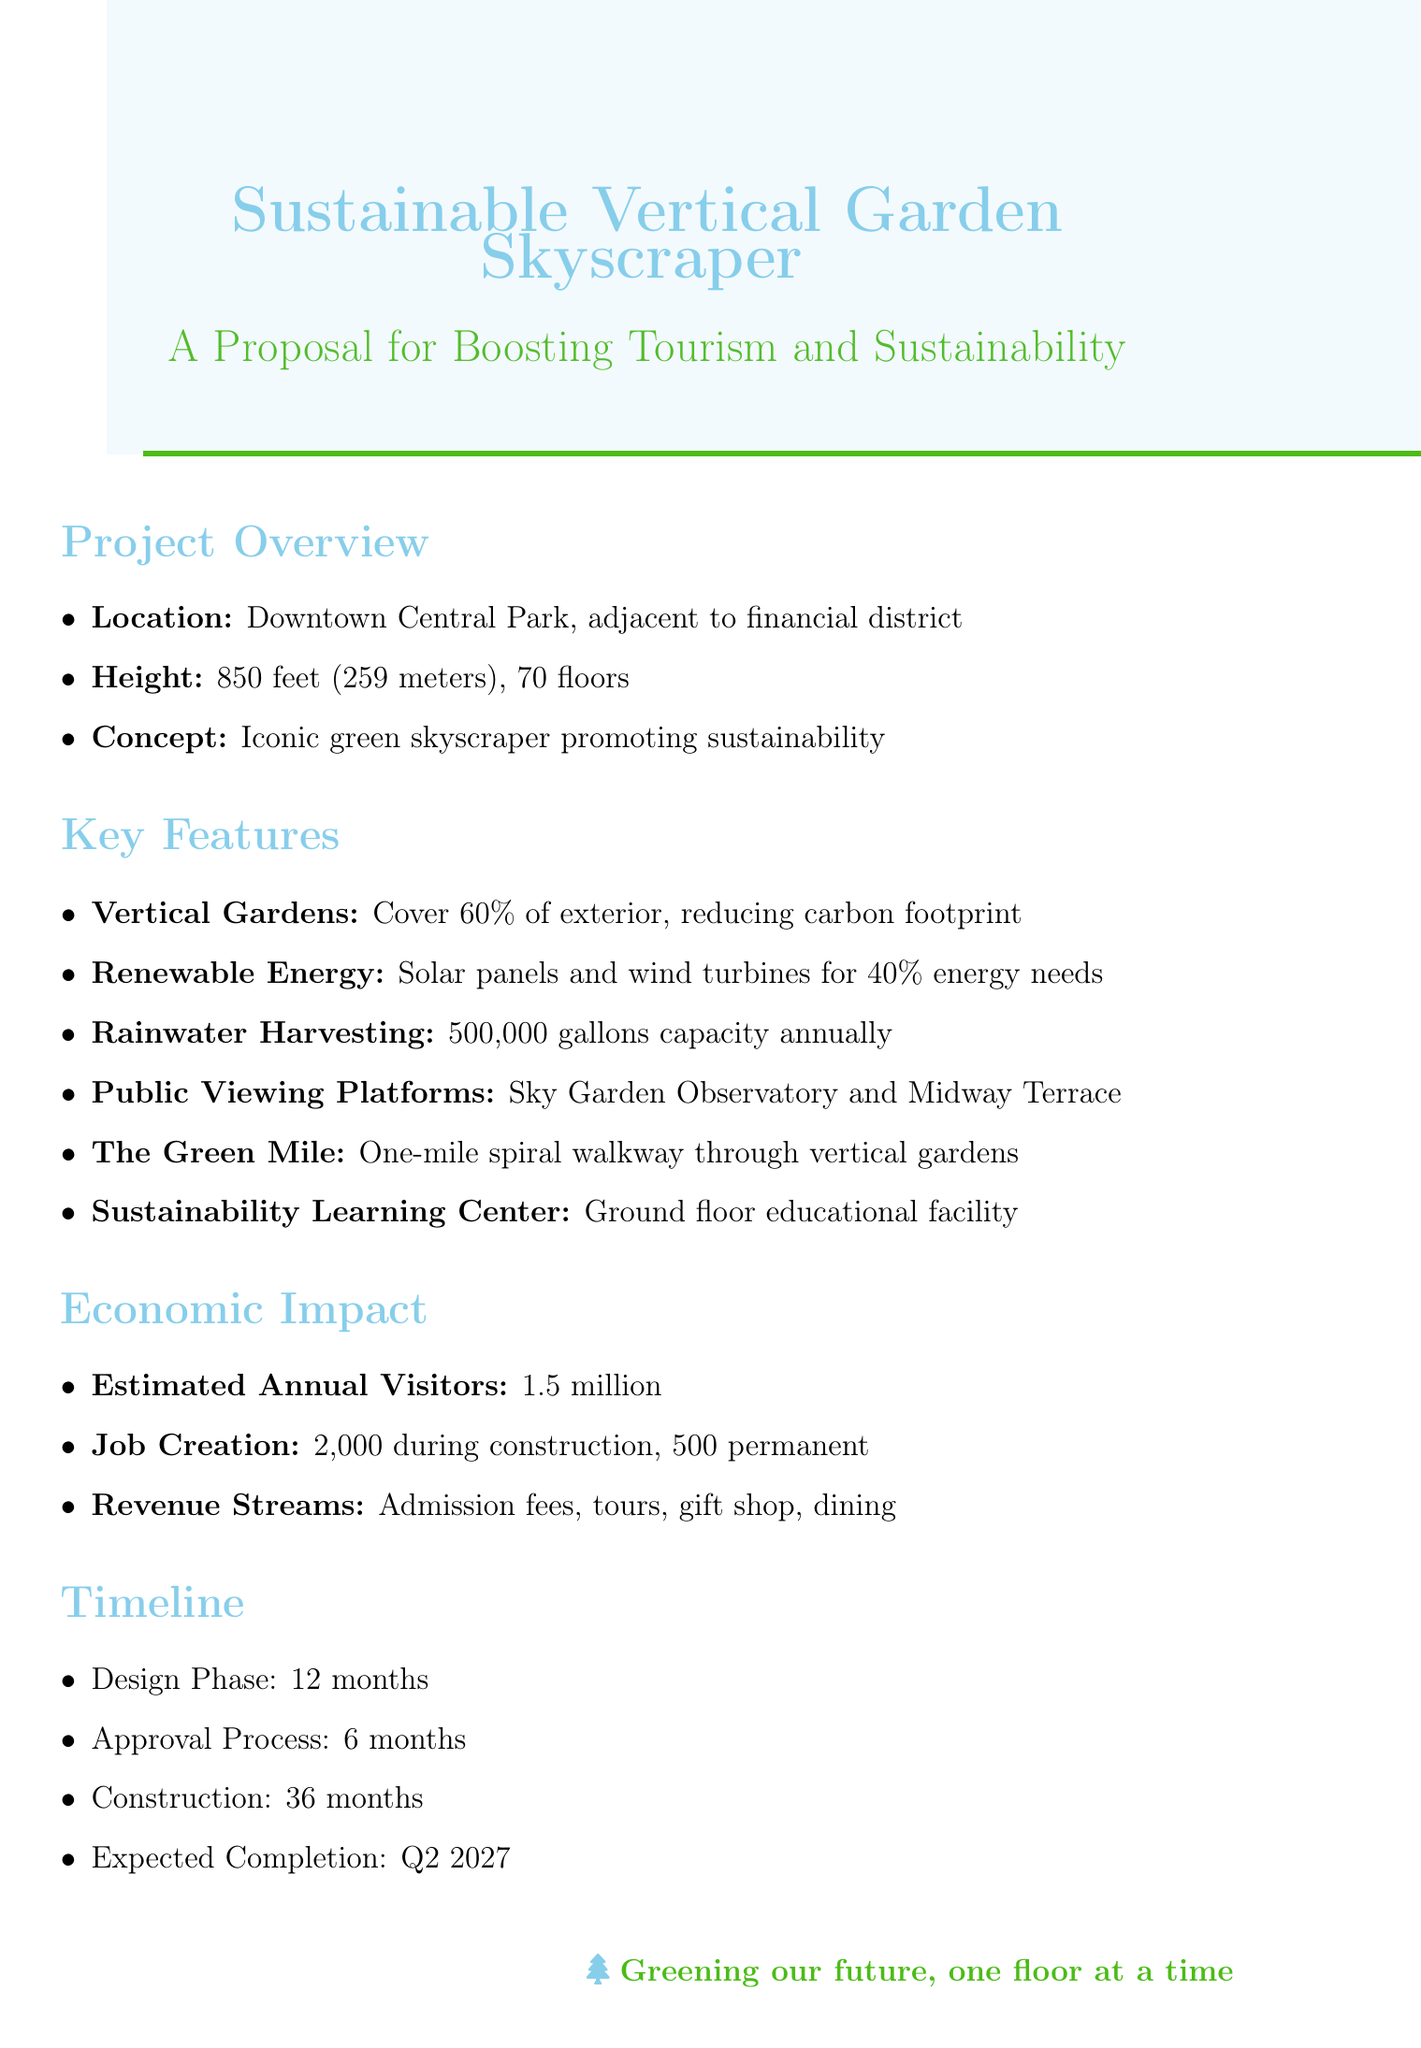What is the height of the skyscraper? The document states that the height of the skyscraper is 850 feet (259 meters).
Answer: 850 feet (259 meters) What are the total estimated annual visitors? The total estimated annual visitors is mentioned as 1.5 million in the economic impact section.
Answer: 1.5 million How many floors will the skyscraper have? The document specifies that the skyscraper will have 70 floors.
Answer: 70 floors What is the name of the public viewing platform located on the 35th floor? The document lists "Midway Terrace" as the public viewing platform on the 35th floor.
Answer: Midway Terrace What is the expected completion date of the project? The document indicates that the expected completion date is Q2 2027.
Answer: Q2 2027 How much electricity will the solar panels produce? The document states that solar panels will produce 30% of the building's electricity needs.
Answer: 30% What is the purpose of the Sustainability Learning Center? According to the document, the Sustainability Learning Center is an educational facility for schools and the public to learn about green technologies.
Answer: Educational facility What is one revenue source mentioned in the economic impact section? The document mentions several revenue sources, including admission fees, which is one of them.
Answer: Admission fees Which organization is responsible for sustainability certification? The document identifies the Green Building Council as the organization for sustainability certification and guidance.
Answer: Green Building Council 